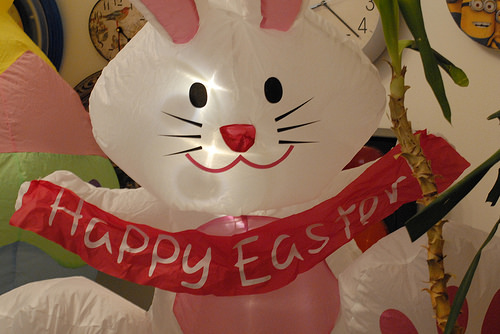<image>
Is the rabbit on the paper? No. The rabbit is not positioned on the paper. They may be near each other, but the rabbit is not supported by or resting on top of the paper. 